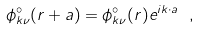Convert formula to latex. <formula><loc_0><loc_0><loc_500><loc_500>\phi ^ { \circ } _ { { k } \nu } ( { r + a } ) = \phi ^ { \circ } _ { { k } \nu } ( { r } ) e ^ { i { k } \cdot { a } } \ ,</formula> 